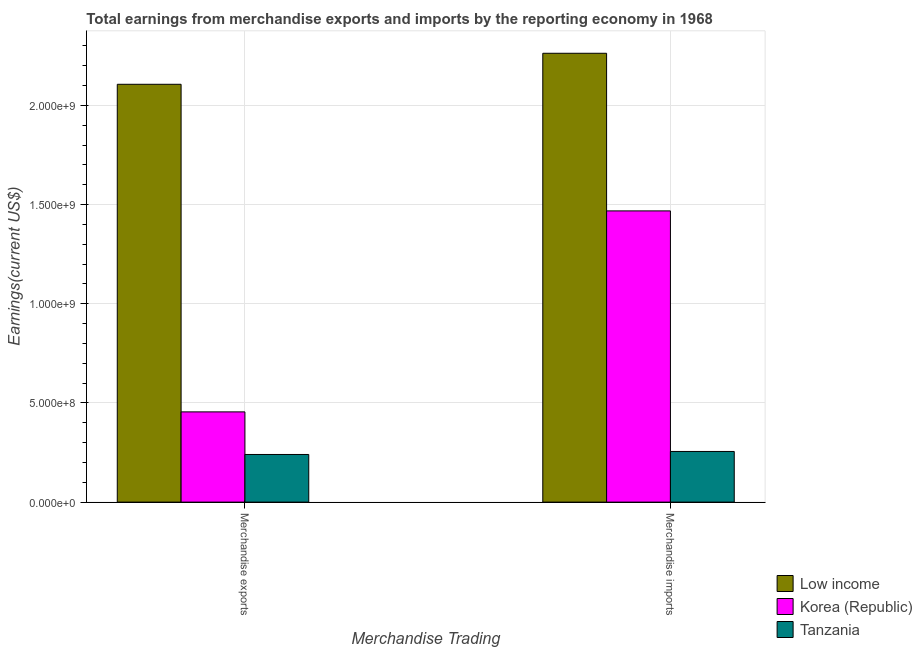How many groups of bars are there?
Offer a terse response. 2. Are the number of bars per tick equal to the number of legend labels?
Your answer should be very brief. Yes. What is the label of the 1st group of bars from the left?
Your answer should be compact. Merchandise exports. What is the earnings from merchandise exports in Tanzania?
Give a very brief answer. 2.40e+08. Across all countries, what is the maximum earnings from merchandise exports?
Give a very brief answer. 2.11e+09. Across all countries, what is the minimum earnings from merchandise imports?
Make the answer very short. 2.55e+08. In which country was the earnings from merchandise exports minimum?
Make the answer very short. Tanzania. What is the total earnings from merchandise imports in the graph?
Give a very brief answer. 3.99e+09. What is the difference between the earnings from merchandise exports in Tanzania and that in Korea (Republic)?
Your response must be concise. -2.15e+08. What is the difference between the earnings from merchandise exports in Korea (Republic) and the earnings from merchandise imports in Tanzania?
Your response must be concise. 2.00e+08. What is the average earnings from merchandise imports per country?
Give a very brief answer. 1.33e+09. What is the difference between the earnings from merchandise exports and earnings from merchandise imports in Low income?
Your response must be concise. -1.56e+08. What is the ratio of the earnings from merchandise imports in Tanzania to that in Low income?
Give a very brief answer. 0.11. In how many countries, is the earnings from merchandise exports greater than the average earnings from merchandise exports taken over all countries?
Ensure brevity in your answer.  1. How many bars are there?
Make the answer very short. 6. Are all the bars in the graph horizontal?
Provide a short and direct response. No. How many countries are there in the graph?
Provide a succinct answer. 3. Does the graph contain any zero values?
Your response must be concise. No. Does the graph contain grids?
Provide a short and direct response. Yes. What is the title of the graph?
Provide a succinct answer. Total earnings from merchandise exports and imports by the reporting economy in 1968. Does "Korea (Republic)" appear as one of the legend labels in the graph?
Offer a terse response. Yes. What is the label or title of the X-axis?
Your answer should be very brief. Merchandise Trading. What is the label or title of the Y-axis?
Your answer should be compact. Earnings(current US$). What is the Earnings(current US$) of Low income in Merchandise exports?
Give a very brief answer. 2.11e+09. What is the Earnings(current US$) of Korea (Republic) in Merchandise exports?
Ensure brevity in your answer.  4.55e+08. What is the Earnings(current US$) of Tanzania in Merchandise exports?
Make the answer very short. 2.40e+08. What is the Earnings(current US$) of Low income in Merchandise imports?
Keep it short and to the point. 2.26e+09. What is the Earnings(current US$) of Korea (Republic) in Merchandise imports?
Provide a succinct answer. 1.47e+09. What is the Earnings(current US$) of Tanzania in Merchandise imports?
Keep it short and to the point. 2.55e+08. Across all Merchandise Trading, what is the maximum Earnings(current US$) in Low income?
Provide a succinct answer. 2.26e+09. Across all Merchandise Trading, what is the maximum Earnings(current US$) of Korea (Republic)?
Your answer should be compact. 1.47e+09. Across all Merchandise Trading, what is the maximum Earnings(current US$) in Tanzania?
Keep it short and to the point. 2.55e+08. Across all Merchandise Trading, what is the minimum Earnings(current US$) in Low income?
Ensure brevity in your answer.  2.11e+09. Across all Merchandise Trading, what is the minimum Earnings(current US$) in Korea (Republic)?
Keep it short and to the point. 4.55e+08. Across all Merchandise Trading, what is the minimum Earnings(current US$) of Tanzania?
Your answer should be very brief. 2.40e+08. What is the total Earnings(current US$) in Low income in the graph?
Offer a terse response. 4.37e+09. What is the total Earnings(current US$) in Korea (Republic) in the graph?
Your answer should be compact. 1.92e+09. What is the total Earnings(current US$) in Tanzania in the graph?
Offer a very short reply. 4.96e+08. What is the difference between the Earnings(current US$) in Low income in Merchandise exports and that in Merchandise imports?
Give a very brief answer. -1.56e+08. What is the difference between the Earnings(current US$) in Korea (Republic) in Merchandise exports and that in Merchandise imports?
Offer a terse response. -1.01e+09. What is the difference between the Earnings(current US$) in Tanzania in Merchandise exports and that in Merchandise imports?
Provide a short and direct response. -1.52e+07. What is the difference between the Earnings(current US$) in Low income in Merchandise exports and the Earnings(current US$) in Korea (Republic) in Merchandise imports?
Offer a very short reply. 6.38e+08. What is the difference between the Earnings(current US$) in Low income in Merchandise exports and the Earnings(current US$) in Tanzania in Merchandise imports?
Offer a terse response. 1.85e+09. What is the difference between the Earnings(current US$) in Korea (Republic) in Merchandise exports and the Earnings(current US$) in Tanzania in Merchandise imports?
Your answer should be very brief. 2.00e+08. What is the average Earnings(current US$) in Low income per Merchandise Trading?
Make the answer very short. 2.18e+09. What is the average Earnings(current US$) in Korea (Republic) per Merchandise Trading?
Give a very brief answer. 9.61e+08. What is the average Earnings(current US$) in Tanzania per Merchandise Trading?
Your answer should be compact. 2.48e+08. What is the difference between the Earnings(current US$) in Low income and Earnings(current US$) in Korea (Republic) in Merchandise exports?
Offer a very short reply. 1.65e+09. What is the difference between the Earnings(current US$) in Low income and Earnings(current US$) in Tanzania in Merchandise exports?
Offer a very short reply. 1.87e+09. What is the difference between the Earnings(current US$) of Korea (Republic) and Earnings(current US$) of Tanzania in Merchandise exports?
Provide a short and direct response. 2.15e+08. What is the difference between the Earnings(current US$) of Low income and Earnings(current US$) of Korea (Republic) in Merchandise imports?
Ensure brevity in your answer.  7.95e+08. What is the difference between the Earnings(current US$) in Low income and Earnings(current US$) in Tanzania in Merchandise imports?
Offer a very short reply. 2.01e+09. What is the difference between the Earnings(current US$) of Korea (Republic) and Earnings(current US$) of Tanzania in Merchandise imports?
Provide a short and direct response. 1.21e+09. What is the ratio of the Earnings(current US$) in Low income in Merchandise exports to that in Merchandise imports?
Give a very brief answer. 0.93. What is the ratio of the Earnings(current US$) in Korea (Republic) in Merchandise exports to that in Merchandise imports?
Offer a very short reply. 0.31. What is the ratio of the Earnings(current US$) of Tanzania in Merchandise exports to that in Merchandise imports?
Your response must be concise. 0.94. What is the difference between the highest and the second highest Earnings(current US$) of Low income?
Offer a very short reply. 1.56e+08. What is the difference between the highest and the second highest Earnings(current US$) of Korea (Republic)?
Make the answer very short. 1.01e+09. What is the difference between the highest and the second highest Earnings(current US$) of Tanzania?
Your response must be concise. 1.52e+07. What is the difference between the highest and the lowest Earnings(current US$) in Low income?
Offer a terse response. 1.56e+08. What is the difference between the highest and the lowest Earnings(current US$) in Korea (Republic)?
Give a very brief answer. 1.01e+09. What is the difference between the highest and the lowest Earnings(current US$) in Tanzania?
Your answer should be compact. 1.52e+07. 